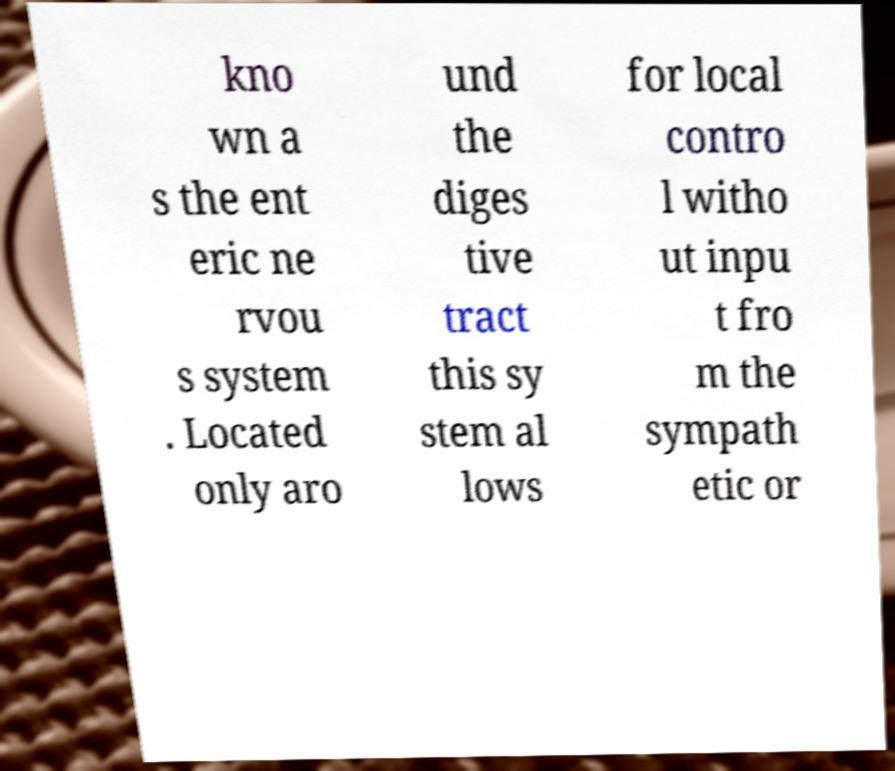Can you read and provide the text displayed in the image?This photo seems to have some interesting text. Can you extract and type it out for me? kno wn a s the ent eric ne rvou s system . Located only aro und the diges tive tract this sy stem al lows for local contro l witho ut inpu t fro m the sympath etic or 